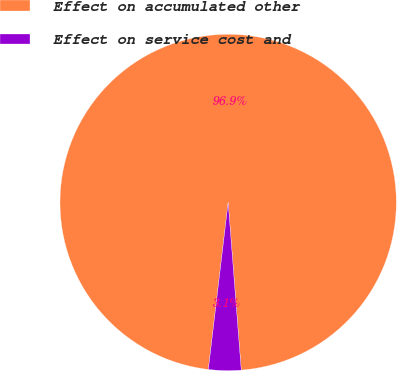<chart> <loc_0><loc_0><loc_500><loc_500><pie_chart><fcel>Effect on accumulated other<fcel>Effect on service cost and<nl><fcel>96.88%<fcel>3.12%<nl></chart> 